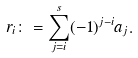Convert formula to latex. <formula><loc_0><loc_0><loc_500><loc_500>r _ { i } \colon = \sum _ { j = i } ^ { s } ( - 1 ) ^ { j - i } a _ { j } .</formula> 